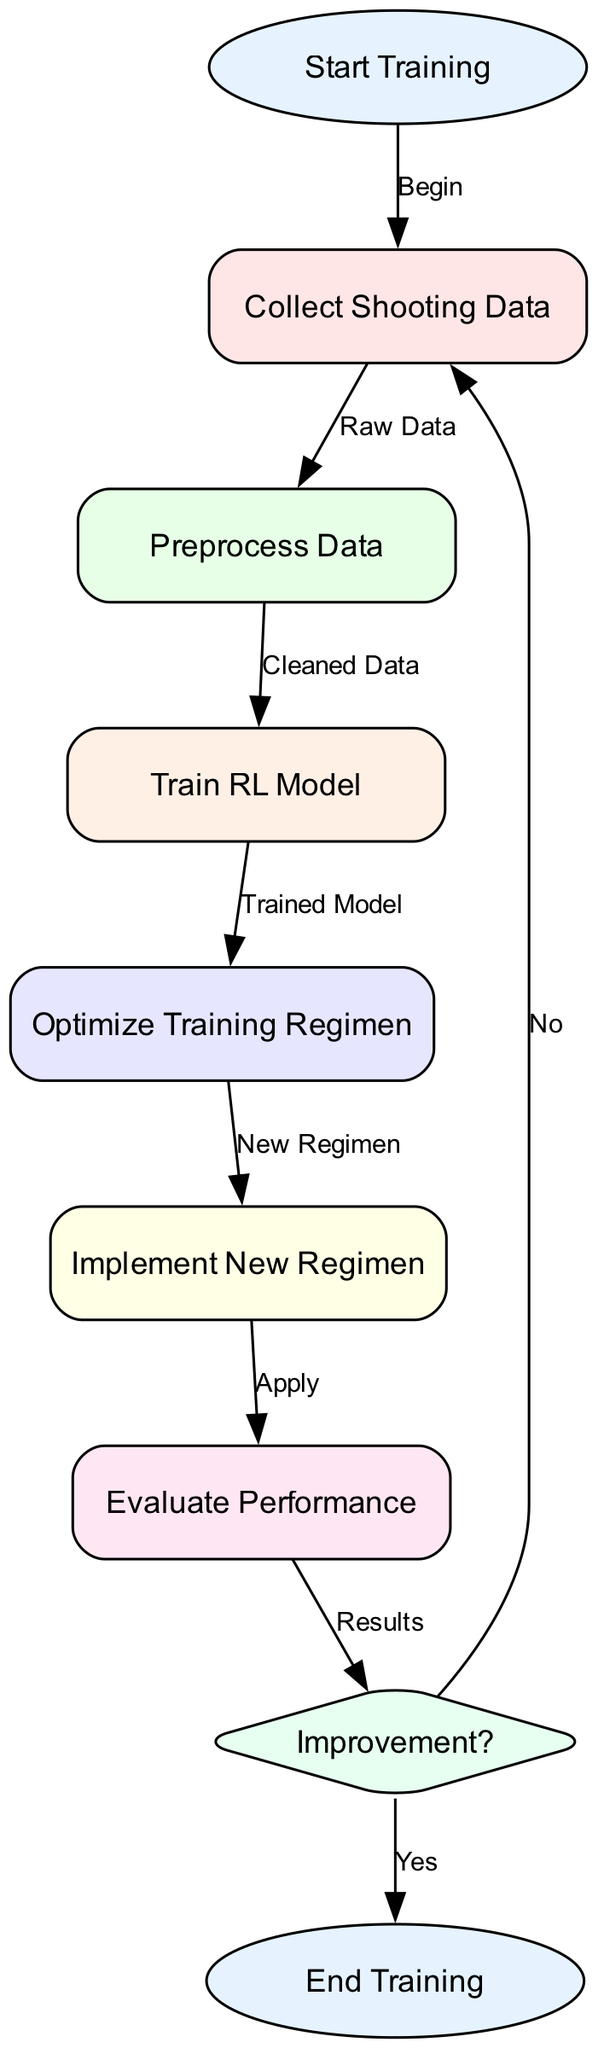What is the first step in the diagram? The first node in the diagram is labeled "Start Training," indicating that this is the initial step in the process.
Answer: Start Training How many nodes are present in the diagram? By counting the unique nodes listed, we find that there are eight nodes in total.
Answer: Eight What is the output of the "Train RL Model" stage? The output from the "Train RL Model" node leads to the "Optimize Training Regimen" node, as indicated by the connecting edge labeled "Trained Model."
Answer: Optimize Training Regimen What action is taken if the evaluation shows "Improvement?" If the evaluation finds an improvement, the process will end, as indicated by the "Yes" edge leading to the "End Training" node.
Answer: End Training What happens after "Implement New Regimen"? Following the "Implement New Regimen," the next step is "Evaluate Performance," as shown by the edge labeled "Apply."
Answer: Evaluate Performance Which node represents a decision point in the flowchart? The node labeled "Improvement?" is diamond-shaped, indicating that it serves as a decision point within the flowchart structure.
Answer: Improvement? What does the "Collect Shooting Data" node lead to? The "Collect Shooting Data" node directs to the "Preprocess Data" node, indicated by the edge labeled "Raw Data."
Answer: Preprocess Data What is the final output of this flowchart after evaluation? The final output after all processes, if no improvement is found, is the "End Training" node, leading to the conclusion of the regimen optimization.
Answer: End Training 